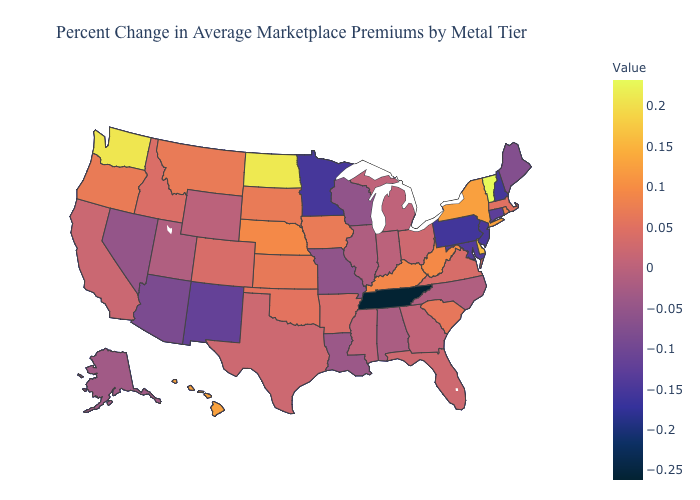Does Connecticut have a higher value than South Carolina?
Quick response, please. No. Which states have the lowest value in the USA?
Keep it brief. Tennessee. 